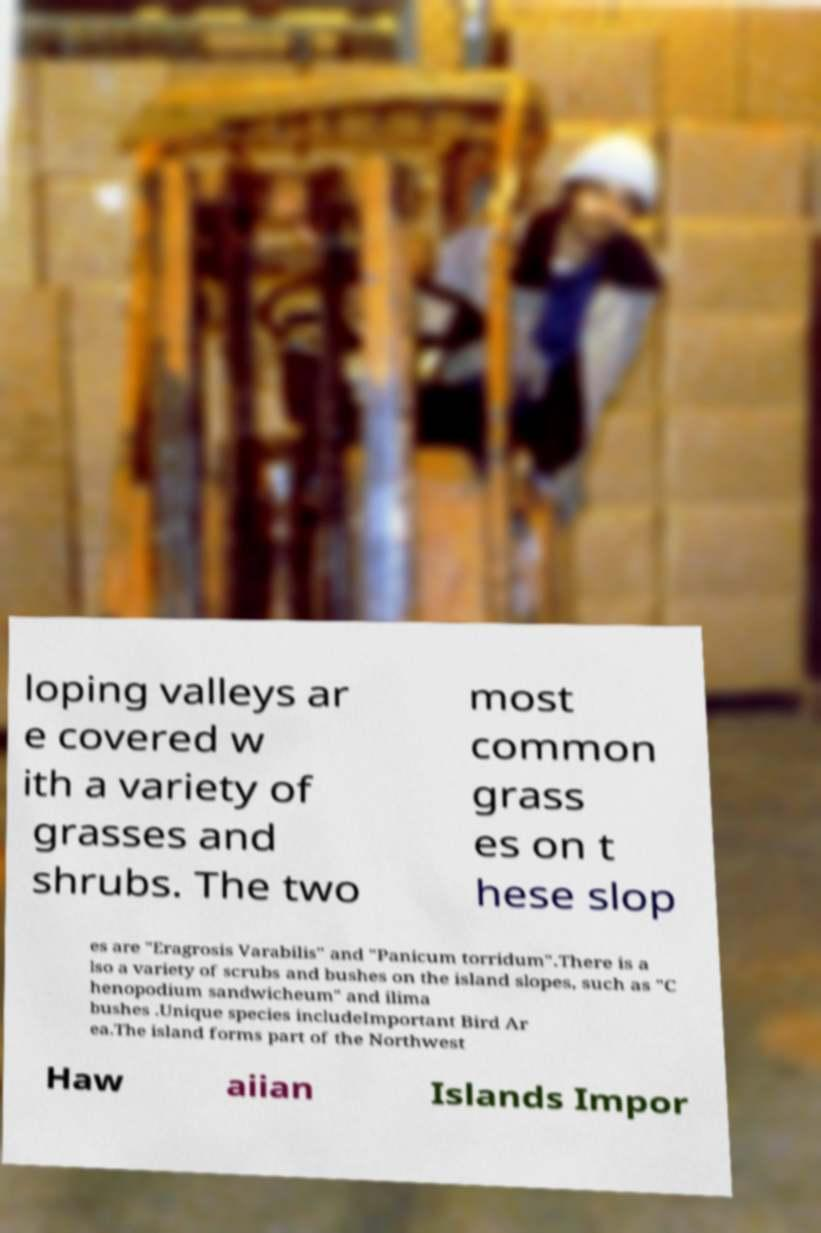Please identify and transcribe the text found in this image. loping valleys ar e covered w ith a variety of grasses and shrubs. The two most common grass es on t hese slop es are "Eragrosis Varabilis" and "Panicum torridum".There is a lso a variety of scrubs and bushes on the island slopes, such as "C henopodium sandwicheum" and ilima bushes .Unique species includeImportant Bird Ar ea.The island forms part of the Northwest Haw aiian Islands Impor 